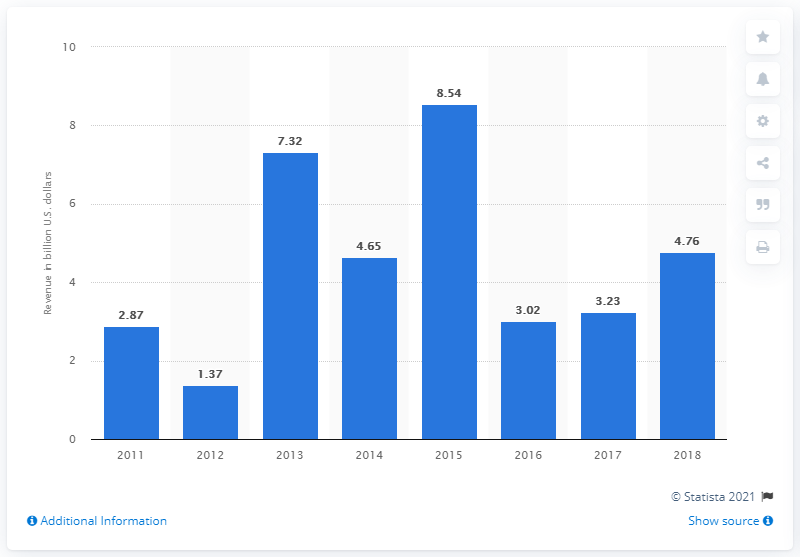Give some essential details in this illustration. In the fiscal year 2018, Twenty First Century Fox generated a net income of 4.76 billion dollars. 